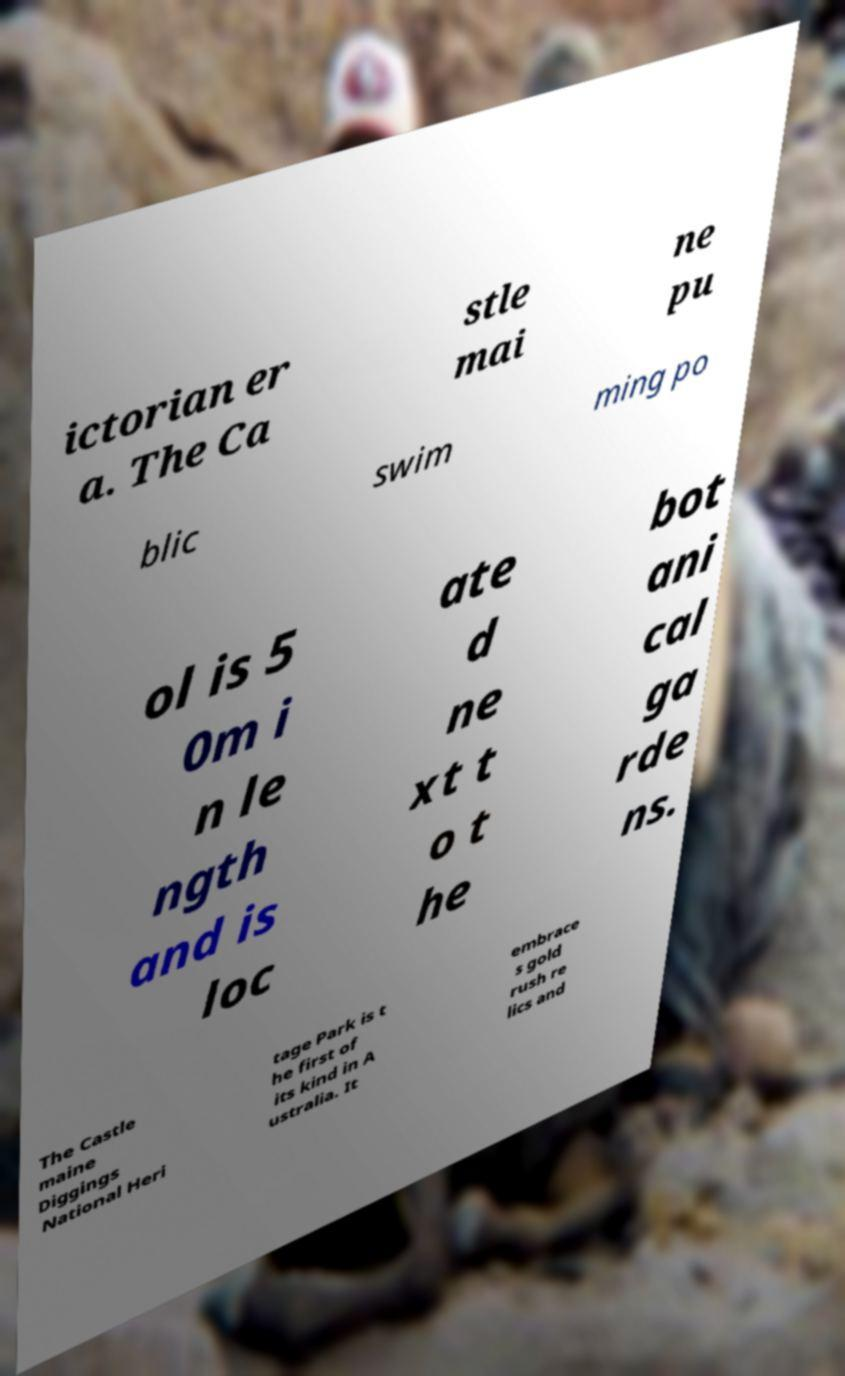I need the written content from this picture converted into text. Can you do that? ictorian er a. The Ca stle mai ne pu blic swim ming po ol is 5 0m i n le ngth and is loc ate d ne xt t o t he bot ani cal ga rde ns. The Castle maine Diggings National Heri tage Park is t he first of its kind in A ustralia. It embrace s gold rush re lics and 